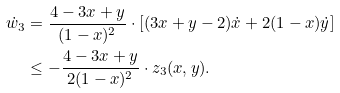<formula> <loc_0><loc_0><loc_500><loc_500>\dot { w } _ { 3 } & = \frac { 4 - 3 x + y } { ( 1 - x ) ^ { 2 } } \cdot \left [ ( 3 x + y - 2 ) \dot { x } + 2 ( 1 - x ) \dot { y } \right ] \\ & \leq - \frac { 4 - 3 x + y } { 2 ( 1 - x ) ^ { 2 } } \cdot z _ { 3 } ( x , y ) .</formula> 